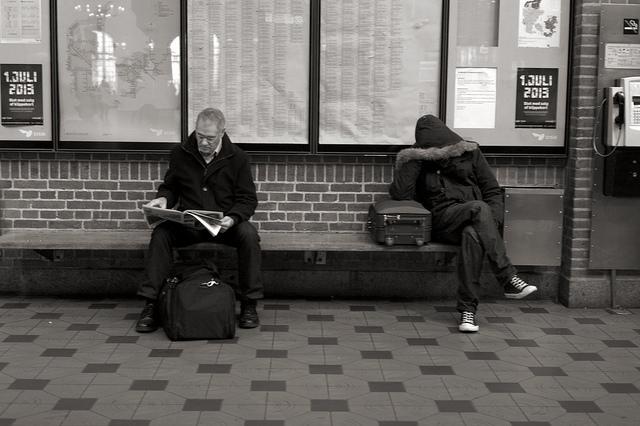What is the person on the left doing?
Quick response, please. Reading. Is this guy good-looking?
Be succinct. No. Is there a phone in this picture?
Keep it brief. Yes. What kind of business are they in front of?
Answer briefly. Bus stop with schedules. What is running down the side of the building on the left side behind the bench?
Give a very brief answer. Bricks. Are both of these people asleep?
Short answer required. No. What color is the bench in the picture?
Write a very short answer. Brown. 